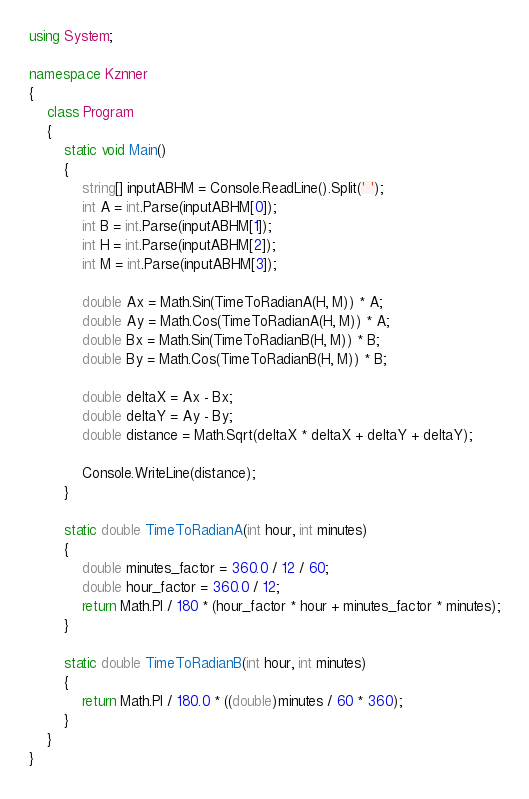Convert code to text. <code><loc_0><loc_0><loc_500><loc_500><_C#_>using System;

namespace Kznner
{
	class Program
	{
		static void Main()
		{
			string[] inputABHM = Console.ReadLine().Split(' ');
			int A = int.Parse(inputABHM[0]);
			int B = int.Parse(inputABHM[1]);
			int H = int.Parse(inputABHM[2]);
			int M = int.Parse(inputABHM[3]);

			double Ax = Math.Sin(TimeToRadianA(H, M)) * A;
			double Ay = Math.Cos(TimeToRadianA(H, M)) * A;
			double Bx = Math.Sin(TimeToRadianB(H, M)) * B;
			double By = Math.Cos(TimeToRadianB(H, M)) * B;

			double deltaX = Ax - Bx;
			double deltaY = Ay - By;
			double distance = Math.Sqrt(deltaX * deltaX + deltaY + deltaY);

			Console.WriteLine(distance);
		}

		static double TimeToRadianA(int hour, int minutes)
		{
			double minutes_factor = 360.0 / 12 / 60;
			double hour_factor = 360.0 / 12;
			return Math.PI / 180 * (hour_factor * hour + minutes_factor * minutes);
		}

		static double TimeToRadianB(int hour, int minutes)
		{
			return Math.PI / 180.0 * ((double)minutes / 60 * 360);
		}
	}
}</code> 